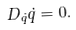Convert formula to latex. <formula><loc_0><loc_0><loc_500><loc_500>D _ { \dot { q } } \dot { q } = 0 .</formula> 